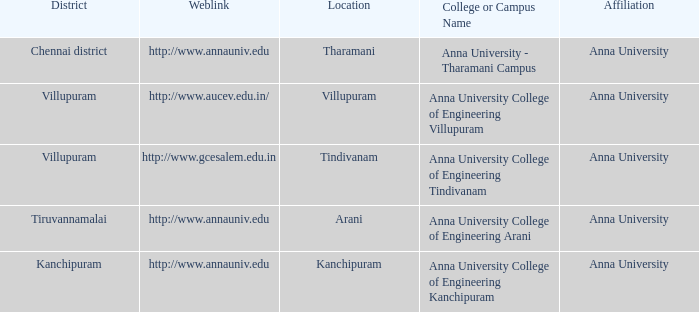What District has a Location of villupuram? Villupuram. 